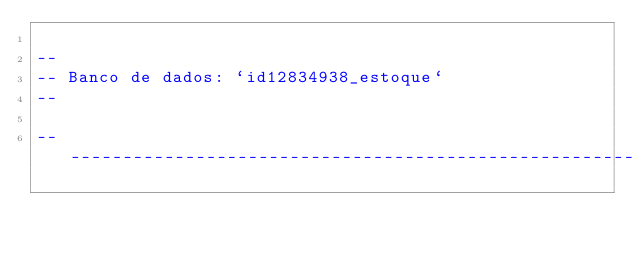Convert code to text. <code><loc_0><loc_0><loc_500><loc_500><_SQL_>
--
-- Banco de dados: `id12834938_estoque`
--

-- --------------------------------------------------------
</code> 